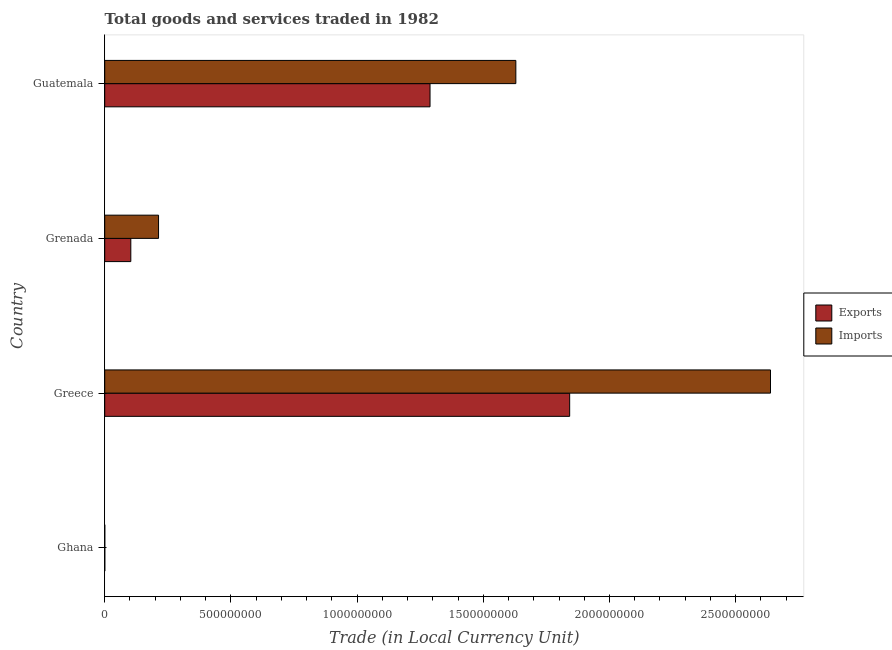How many different coloured bars are there?
Offer a terse response. 2. How many groups of bars are there?
Keep it short and to the point. 4. Are the number of bars per tick equal to the number of legend labels?
Offer a terse response. Yes. Are the number of bars on each tick of the Y-axis equal?
Offer a terse response. Yes. What is the label of the 2nd group of bars from the top?
Your answer should be compact. Grenada. In how many cases, is the number of bars for a given country not equal to the number of legend labels?
Provide a short and direct response. 0. What is the export of goods and services in Guatemala?
Give a very brief answer. 1.29e+09. Across all countries, what is the maximum export of goods and services?
Your answer should be compact. 1.84e+09. Across all countries, what is the minimum export of goods and services?
Keep it short and to the point. 2.89e+05. In which country was the imports of goods and services maximum?
Your answer should be very brief. Greece. In which country was the imports of goods and services minimum?
Provide a short and direct response. Ghana. What is the total export of goods and services in the graph?
Ensure brevity in your answer.  3.23e+09. What is the difference between the imports of goods and services in Greece and that in Grenada?
Your answer should be compact. 2.42e+09. What is the difference between the export of goods and services in Grenada and the imports of goods and services in Greece?
Offer a very short reply. -2.53e+09. What is the average export of goods and services per country?
Provide a succinct answer. 8.09e+08. What is the difference between the export of goods and services and imports of goods and services in Grenada?
Provide a succinct answer. -1.10e+08. In how many countries, is the export of goods and services greater than 2600000000 LCU?
Keep it short and to the point. 0. What is the ratio of the imports of goods and services in Greece to that in Grenada?
Your answer should be very brief. 12.37. Is the imports of goods and services in Grenada less than that in Guatemala?
Your answer should be compact. Yes. What is the difference between the highest and the second highest export of goods and services?
Your response must be concise. 5.53e+08. What is the difference between the highest and the lowest export of goods and services?
Ensure brevity in your answer.  1.84e+09. In how many countries, is the imports of goods and services greater than the average imports of goods and services taken over all countries?
Provide a succinct answer. 2. What does the 1st bar from the top in Greece represents?
Ensure brevity in your answer.  Imports. What does the 1st bar from the bottom in Greece represents?
Ensure brevity in your answer.  Exports. How many bars are there?
Keep it short and to the point. 8. How many countries are there in the graph?
Keep it short and to the point. 4. Are the values on the major ticks of X-axis written in scientific E-notation?
Provide a succinct answer. No. Does the graph contain grids?
Provide a succinct answer. No. How are the legend labels stacked?
Offer a terse response. Vertical. What is the title of the graph?
Provide a succinct answer. Total goods and services traded in 1982. What is the label or title of the X-axis?
Ensure brevity in your answer.  Trade (in Local Currency Unit). What is the label or title of the Y-axis?
Make the answer very short. Country. What is the Trade (in Local Currency Unit) in Exports in Ghana?
Offer a very short reply. 2.89e+05. What is the Trade (in Local Currency Unit) of Imports in Ghana?
Provide a succinct answer. 2.58e+05. What is the Trade (in Local Currency Unit) of Exports in Greece?
Give a very brief answer. 1.84e+09. What is the Trade (in Local Currency Unit) of Imports in Greece?
Give a very brief answer. 2.64e+09. What is the Trade (in Local Currency Unit) in Exports in Grenada?
Keep it short and to the point. 1.03e+08. What is the Trade (in Local Currency Unit) in Imports in Grenada?
Provide a short and direct response. 2.13e+08. What is the Trade (in Local Currency Unit) of Exports in Guatemala?
Provide a short and direct response. 1.29e+09. What is the Trade (in Local Currency Unit) of Imports in Guatemala?
Make the answer very short. 1.63e+09. Across all countries, what is the maximum Trade (in Local Currency Unit) in Exports?
Offer a very short reply. 1.84e+09. Across all countries, what is the maximum Trade (in Local Currency Unit) in Imports?
Give a very brief answer. 2.64e+09. Across all countries, what is the minimum Trade (in Local Currency Unit) in Exports?
Keep it short and to the point. 2.89e+05. Across all countries, what is the minimum Trade (in Local Currency Unit) in Imports?
Your response must be concise. 2.58e+05. What is the total Trade (in Local Currency Unit) in Exports in the graph?
Your answer should be compact. 3.23e+09. What is the total Trade (in Local Currency Unit) in Imports in the graph?
Keep it short and to the point. 4.48e+09. What is the difference between the Trade (in Local Currency Unit) in Exports in Ghana and that in Greece?
Provide a short and direct response. -1.84e+09. What is the difference between the Trade (in Local Currency Unit) in Imports in Ghana and that in Greece?
Your response must be concise. -2.64e+09. What is the difference between the Trade (in Local Currency Unit) of Exports in Ghana and that in Grenada?
Provide a short and direct response. -1.03e+08. What is the difference between the Trade (in Local Currency Unit) of Imports in Ghana and that in Grenada?
Your answer should be very brief. -2.13e+08. What is the difference between the Trade (in Local Currency Unit) of Exports in Ghana and that in Guatemala?
Your response must be concise. -1.29e+09. What is the difference between the Trade (in Local Currency Unit) of Imports in Ghana and that in Guatemala?
Your answer should be compact. -1.63e+09. What is the difference between the Trade (in Local Currency Unit) in Exports in Greece and that in Grenada?
Your answer should be compact. 1.74e+09. What is the difference between the Trade (in Local Currency Unit) of Imports in Greece and that in Grenada?
Your answer should be compact. 2.42e+09. What is the difference between the Trade (in Local Currency Unit) of Exports in Greece and that in Guatemala?
Keep it short and to the point. 5.53e+08. What is the difference between the Trade (in Local Currency Unit) in Imports in Greece and that in Guatemala?
Make the answer very short. 1.01e+09. What is the difference between the Trade (in Local Currency Unit) in Exports in Grenada and that in Guatemala?
Offer a very short reply. -1.19e+09. What is the difference between the Trade (in Local Currency Unit) in Imports in Grenada and that in Guatemala?
Your answer should be compact. -1.42e+09. What is the difference between the Trade (in Local Currency Unit) in Exports in Ghana and the Trade (in Local Currency Unit) in Imports in Greece?
Make the answer very short. -2.64e+09. What is the difference between the Trade (in Local Currency Unit) in Exports in Ghana and the Trade (in Local Currency Unit) in Imports in Grenada?
Your answer should be compact. -2.13e+08. What is the difference between the Trade (in Local Currency Unit) of Exports in Ghana and the Trade (in Local Currency Unit) of Imports in Guatemala?
Offer a terse response. -1.63e+09. What is the difference between the Trade (in Local Currency Unit) in Exports in Greece and the Trade (in Local Currency Unit) in Imports in Grenada?
Provide a succinct answer. 1.63e+09. What is the difference between the Trade (in Local Currency Unit) in Exports in Greece and the Trade (in Local Currency Unit) in Imports in Guatemala?
Your answer should be very brief. 2.13e+08. What is the difference between the Trade (in Local Currency Unit) in Exports in Grenada and the Trade (in Local Currency Unit) in Imports in Guatemala?
Provide a succinct answer. -1.53e+09. What is the average Trade (in Local Currency Unit) of Exports per country?
Your response must be concise. 8.09e+08. What is the average Trade (in Local Currency Unit) in Imports per country?
Give a very brief answer. 1.12e+09. What is the difference between the Trade (in Local Currency Unit) in Exports and Trade (in Local Currency Unit) in Imports in Ghana?
Offer a terse response. 3.08e+04. What is the difference between the Trade (in Local Currency Unit) in Exports and Trade (in Local Currency Unit) in Imports in Greece?
Offer a very short reply. -7.96e+08. What is the difference between the Trade (in Local Currency Unit) in Exports and Trade (in Local Currency Unit) in Imports in Grenada?
Your response must be concise. -1.10e+08. What is the difference between the Trade (in Local Currency Unit) in Exports and Trade (in Local Currency Unit) in Imports in Guatemala?
Your response must be concise. -3.40e+08. What is the ratio of the Trade (in Local Currency Unit) of Imports in Ghana to that in Greece?
Your answer should be very brief. 0. What is the ratio of the Trade (in Local Currency Unit) in Exports in Ghana to that in Grenada?
Offer a terse response. 0. What is the ratio of the Trade (in Local Currency Unit) of Imports in Ghana to that in Grenada?
Keep it short and to the point. 0. What is the ratio of the Trade (in Local Currency Unit) of Imports in Ghana to that in Guatemala?
Provide a short and direct response. 0. What is the ratio of the Trade (in Local Currency Unit) in Exports in Greece to that in Grenada?
Provide a short and direct response. 17.82. What is the ratio of the Trade (in Local Currency Unit) of Imports in Greece to that in Grenada?
Your answer should be compact. 12.37. What is the ratio of the Trade (in Local Currency Unit) of Exports in Greece to that in Guatemala?
Offer a very short reply. 1.43. What is the ratio of the Trade (in Local Currency Unit) of Imports in Greece to that in Guatemala?
Give a very brief answer. 1.62. What is the ratio of the Trade (in Local Currency Unit) in Exports in Grenada to that in Guatemala?
Offer a terse response. 0.08. What is the ratio of the Trade (in Local Currency Unit) of Imports in Grenada to that in Guatemala?
Your response must be concise. 0.13. What is the difference between the highest and the second highest Trade (in Local Currency Unit) in Exports?
Ensure brevity in your answer.  5.53e+08. What is the difference between the highest and the second highest Trade (in Local Currency Unit) in Imports?
Keep it short and to the point. 1.01e+09. What is the difference between the highest and the lowest Trade (in Local Currency Unit) in Exports?
Your answer should be very brief. 1.84e+09. What is the difference between the highest and the lowest Trade (in Local Currency Unit) in Imports?
Offer a very short reply. 2.64e+09. 